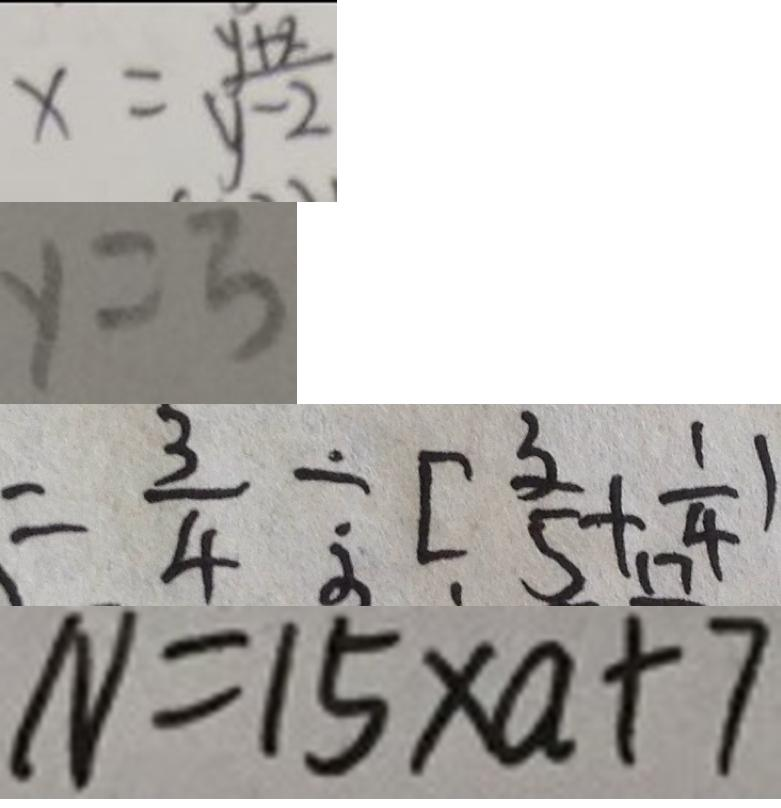<formula> <loc_0><loc_0><loc_500><loc_500>y = \frac { y + 2 } { y - 2 } 
 y = 3 
 = \frac { 3 } { 4 } \div [ \frac { 3 } { 5 } + \frac { 1 } { 4 } ) 
 N = 1 5 \times a + 7</formula> 